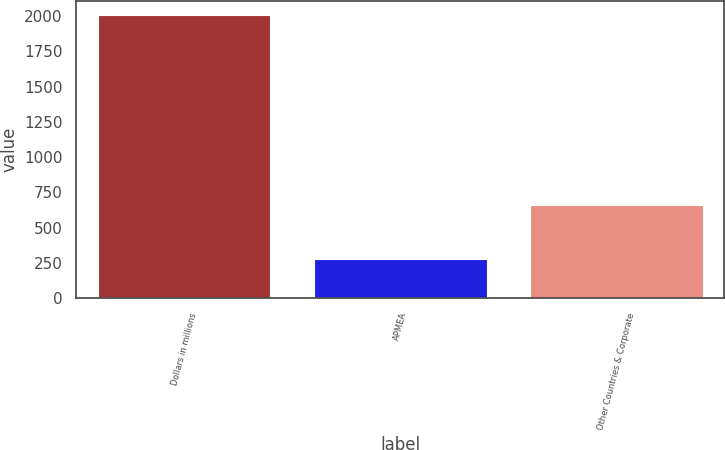Convert chart. <chart><loc_0><loc_0><loc_500><loc_500><bar_chart><fcel>Dollars in millions<fcel>APMEA<fcel>Other Countries & Corporate<nl><fcel>2007<fcel>276<fcel>658<nl></chart> 